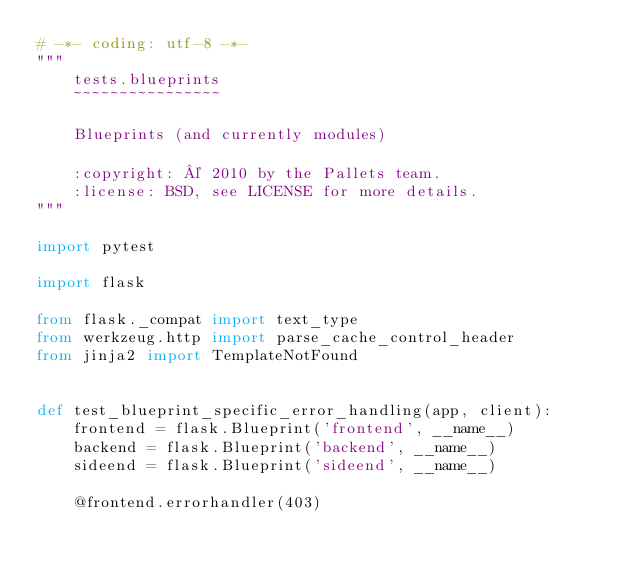Convert code to text. <code><loc_0><loc_0><loc_500><loc_500><_Python_># -*- coding: utf-8 -*-
"""
    tests.blueprints
    ~~~~~~~~~~~~~~~~

    Blueprints (and currently modules)

    :copyright: © 2010 by the Pallets team.
    :license: BSD, see LICENSE for more details.
"""

import pytest

import flask

from flask._compat import text_type
from werkzeug.http import parse_cache_control_header
from jinja2 import TemplateNotFound


def test_blueprint_specific_error_handling(app, client):
    frontend = flask.Blueprint('frontend', __name__)
    backend = flask.Blueprint('backend', __name__)
    sideend = flask.Blueprint('sideend', __name__)

    @frontend.errorhandler(403)</code> 